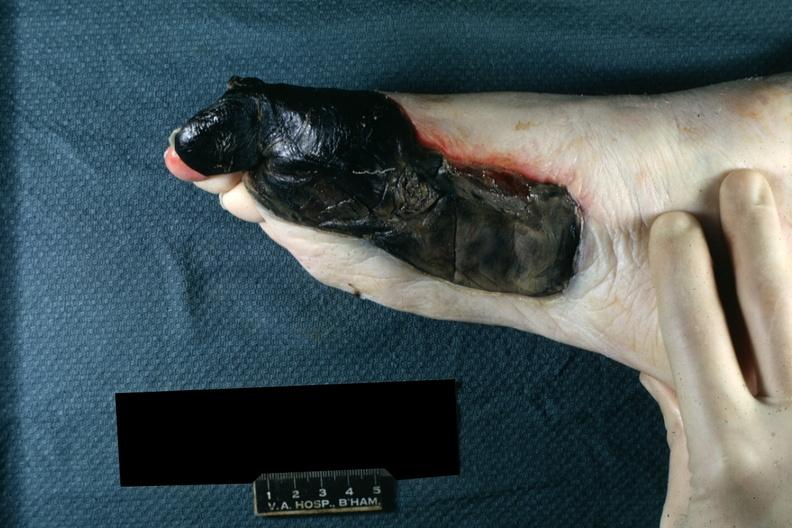what does this image show?
Answer the question using a single word or phrase. Well demarcated gangrenous necrosis medial aspect left foot 